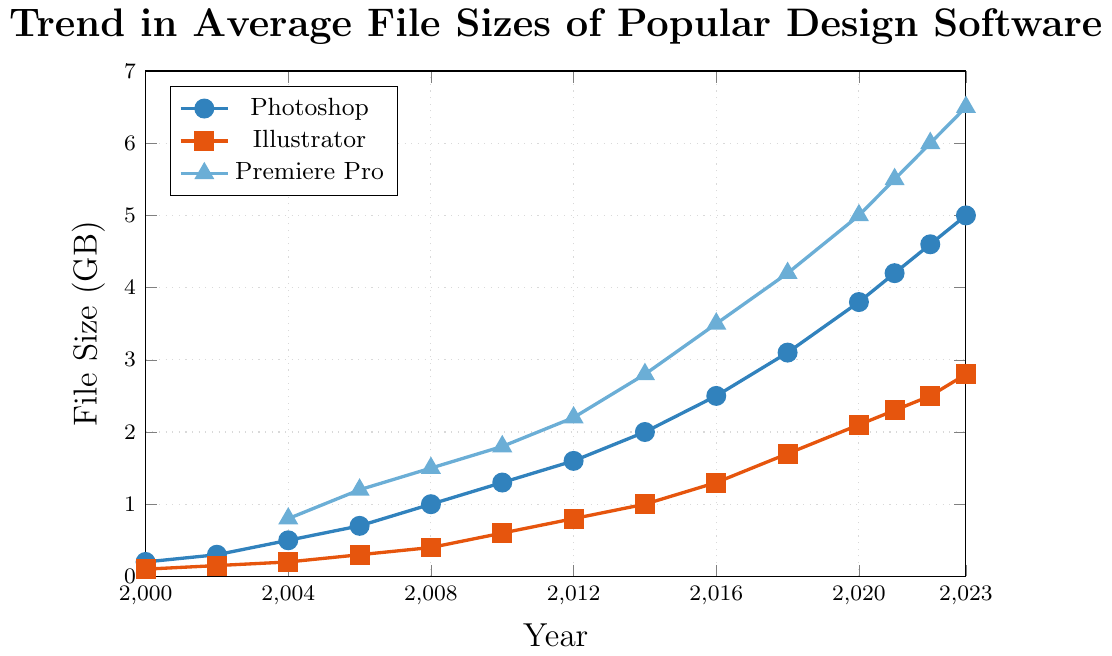What is the year when Photoshop file size first reached over 2 GB? In the chart, look for the point at which the Photoshop (blue line) crosses 2 GB. This occurs in the year 2014.
Answer: 2014 Which software had the highest file size in 2020? Check the file sizes for all three software in the year 2020. Photoshop is 3.8 GB, Illustrator is 2.1 GB, and Premiere Pro is 5.0 GB. Premiere Pro has the highest file size.
Answer: Premiere Pro What was the increase in Illustrator's file size from 2000 to 2023? Illustrator’s file size in 2000 was 0.1 GB, and in 2023 it was 2.8 GB. The increase is calculated as 2.8 GB - 0.1 GB.
Answer: 2.7 GB Between which years did Premiere Pro see the largest increase in file size? Observe the segments of the Premiere Pro line (blue line) to find the largest increase. Noting that from 2018 (4.2 GB) to 2020 (5.0 GB) is an 0.8 GB increase, which is the largest.
Answer: 2018 to 2020 In terms of file size growth, which software has a steeper increasing trend over time, Photoshop or Illustrator? Compare the slopes of both lines over the entire time span. Photoshop’s (blue line) growth is more steeply increasing compared to Illustrator’s (red line).
Answer: Photoshop What is the average file size of Photoshop from 2016 to 2023? Sum the Photoshop file sizes from 2016 (2.5 GB), 2018 (3.1 GB), 2020 (3.8 GB), 2021 (4.2 GB), 2022 (4.6 GB), and 2023 (5.0 GB) and divide by the number of years. (2.5 + 3.1 + 3.8 + 4.2 + 4.6 + 5.0) / 6 = 23.2 / 6 = 3.87
Answer: 3.87 GB Which color represents Illustrator in the chart? Identify the color used for different software in the legend. Illustrator is represented by the orange line with square markers.
Answer: Orange What was the total increase in Photoshop file size from 2000 to 2023? Photoshop’s file size was 0.2 GB in 2000 and 5.0 GB in 2023. The total increase is calculated as 5.0 GB - 0.2 GB.
Answer: 4.8 GB Did any software have a constant file size over any years in the chart? Check if any of the lines remain flat over any period. All software shows continuous growth or change without a flat section.
Answer: No 